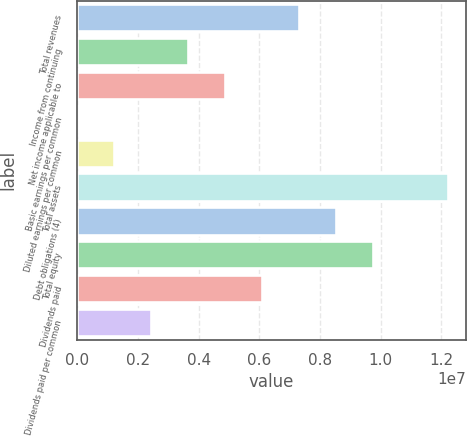Convert chart. <chart><loc_0><loc_0><loc_500><loc_500><bar_chart><fcel>Total revenues<fcel>Income from continuing<fcel>Net income applicable to<fcel>Basic earnings per common<fcel>Diluted earnings per common<fcel>Total assets<fcel>Debt obligations (4)<fcel>Total equity<fcel>Dividends paid<fcel>Dividends paid per common<nl><fcel>7.32584e+06<fcel>3.66292e+06<fcel>4.88389e+06<fcel>0.18<fcel>1.22097e+06<fcel>1.22097e+07<fcel>8.54681e+06<fcel>9.76779e+06<fcel>6.10487e+06<fcel>2.44195e+06<nl></chart> 